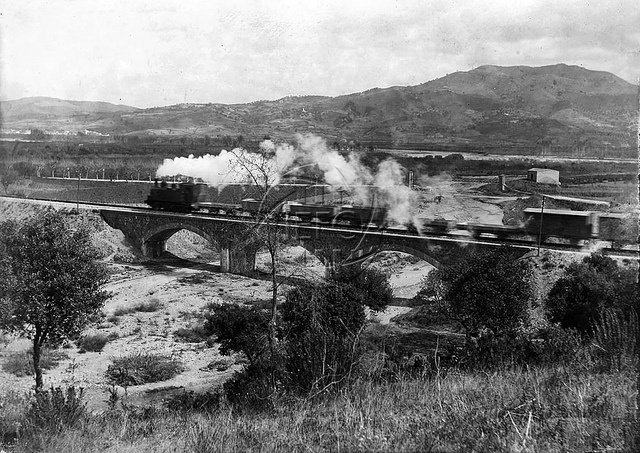Describe the objects in this image and their specific colors. I can see a train in white, black, gray, darkgray, and lightgray tones in this image. 